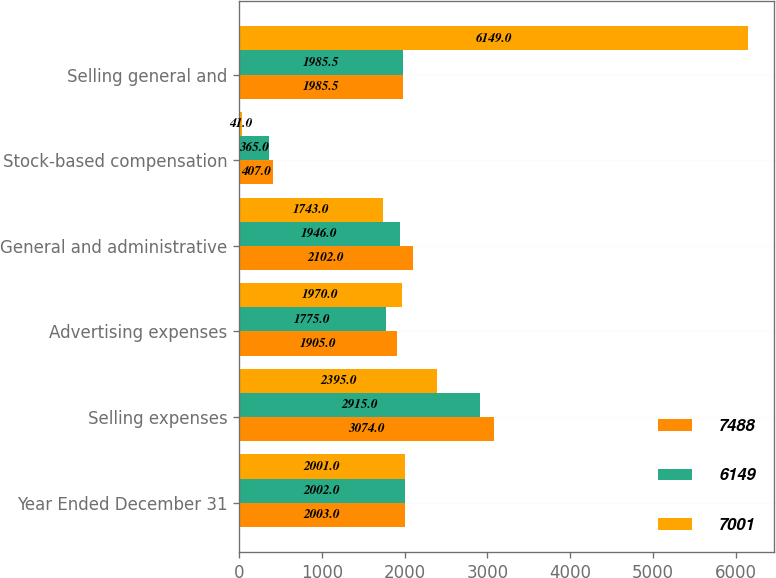Convert chart. <chart><loc_0><loc_0><loc_500><loc_500><stacked_bar_chart><ecel><fcel>Year Ended December 31<fcel>Selling expenses<fcel>Advertising expenses<fcel>General and administrative<fcel>Stock-based compensation<fcel>Selling general and<nl><fcel>7488<fcel>2003<fcel>3074<fcel>1905<fcel>2102<fcel>407<fcel>1985.5<nl><fcel>6149<fcel>2002<fcel>2915<fcel>1775<fcel>1946<fcel>365<fcel>1985.5<nl><fcel>7001<fcel>2001<fcel>2395<fcel>1970<fcel>1743<fcel>41<fcel>6149<nl></chart> 